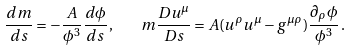<formula> <loc_0><loc_0><loc_500><loc_500>\frac { d m } { d s } = - \frac { A } { \phi ^ { 3 } } \frac { d \phi } { d s } \, , \quad m \frac { D u ^ { \mu } } { D s } = A ( u ^ { \rho } u ^ { \mu } - g ^ { \mu \rho } ) \frac { \partial _ { \rho } \phi } { \phi ^ { 3 } } \, .</formula> 